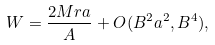Convert formula to latex. <formula><loc_0><loc_0><loc_500><loc_500>W = \frac { 2 M r a } { A } + O ( B ^ { 2 } a ^ { 2 } , B ^ { 4 } ) ,</formula> 